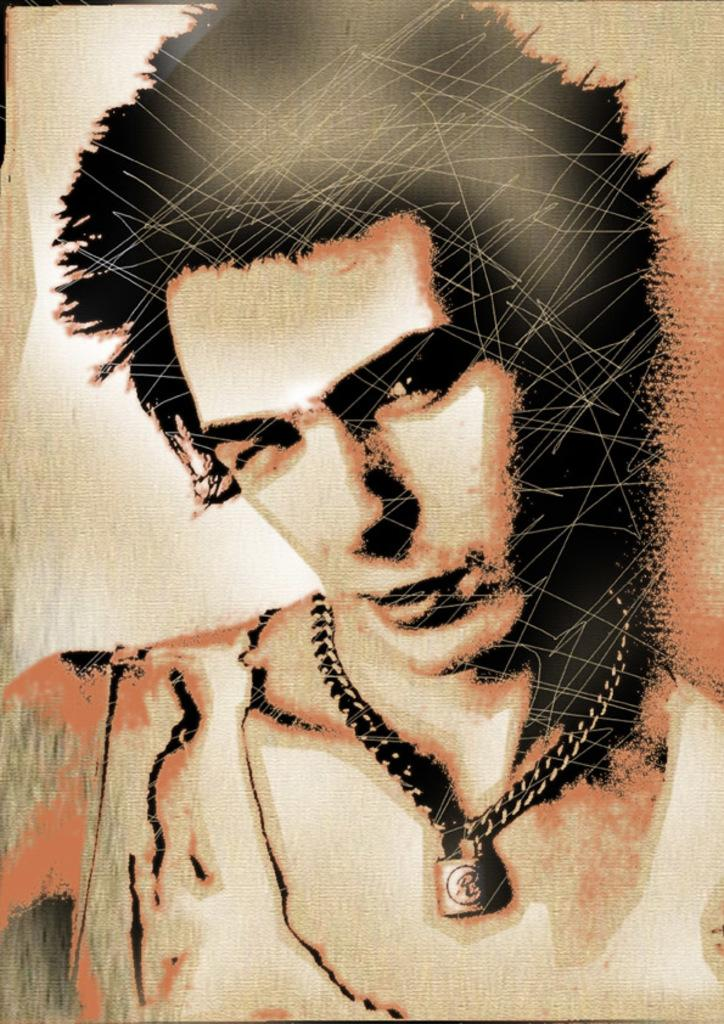What is the main subject of the image? There is a painting in the image. What is depicted in the painting? The painting depicts a man. What is the man wearing in the painting? The man is wearing clothes and a neck chain. What country does the man in the painting suggest visiting? The painting does not suggest visiting any country, as it is a static image and not a form of communication. 